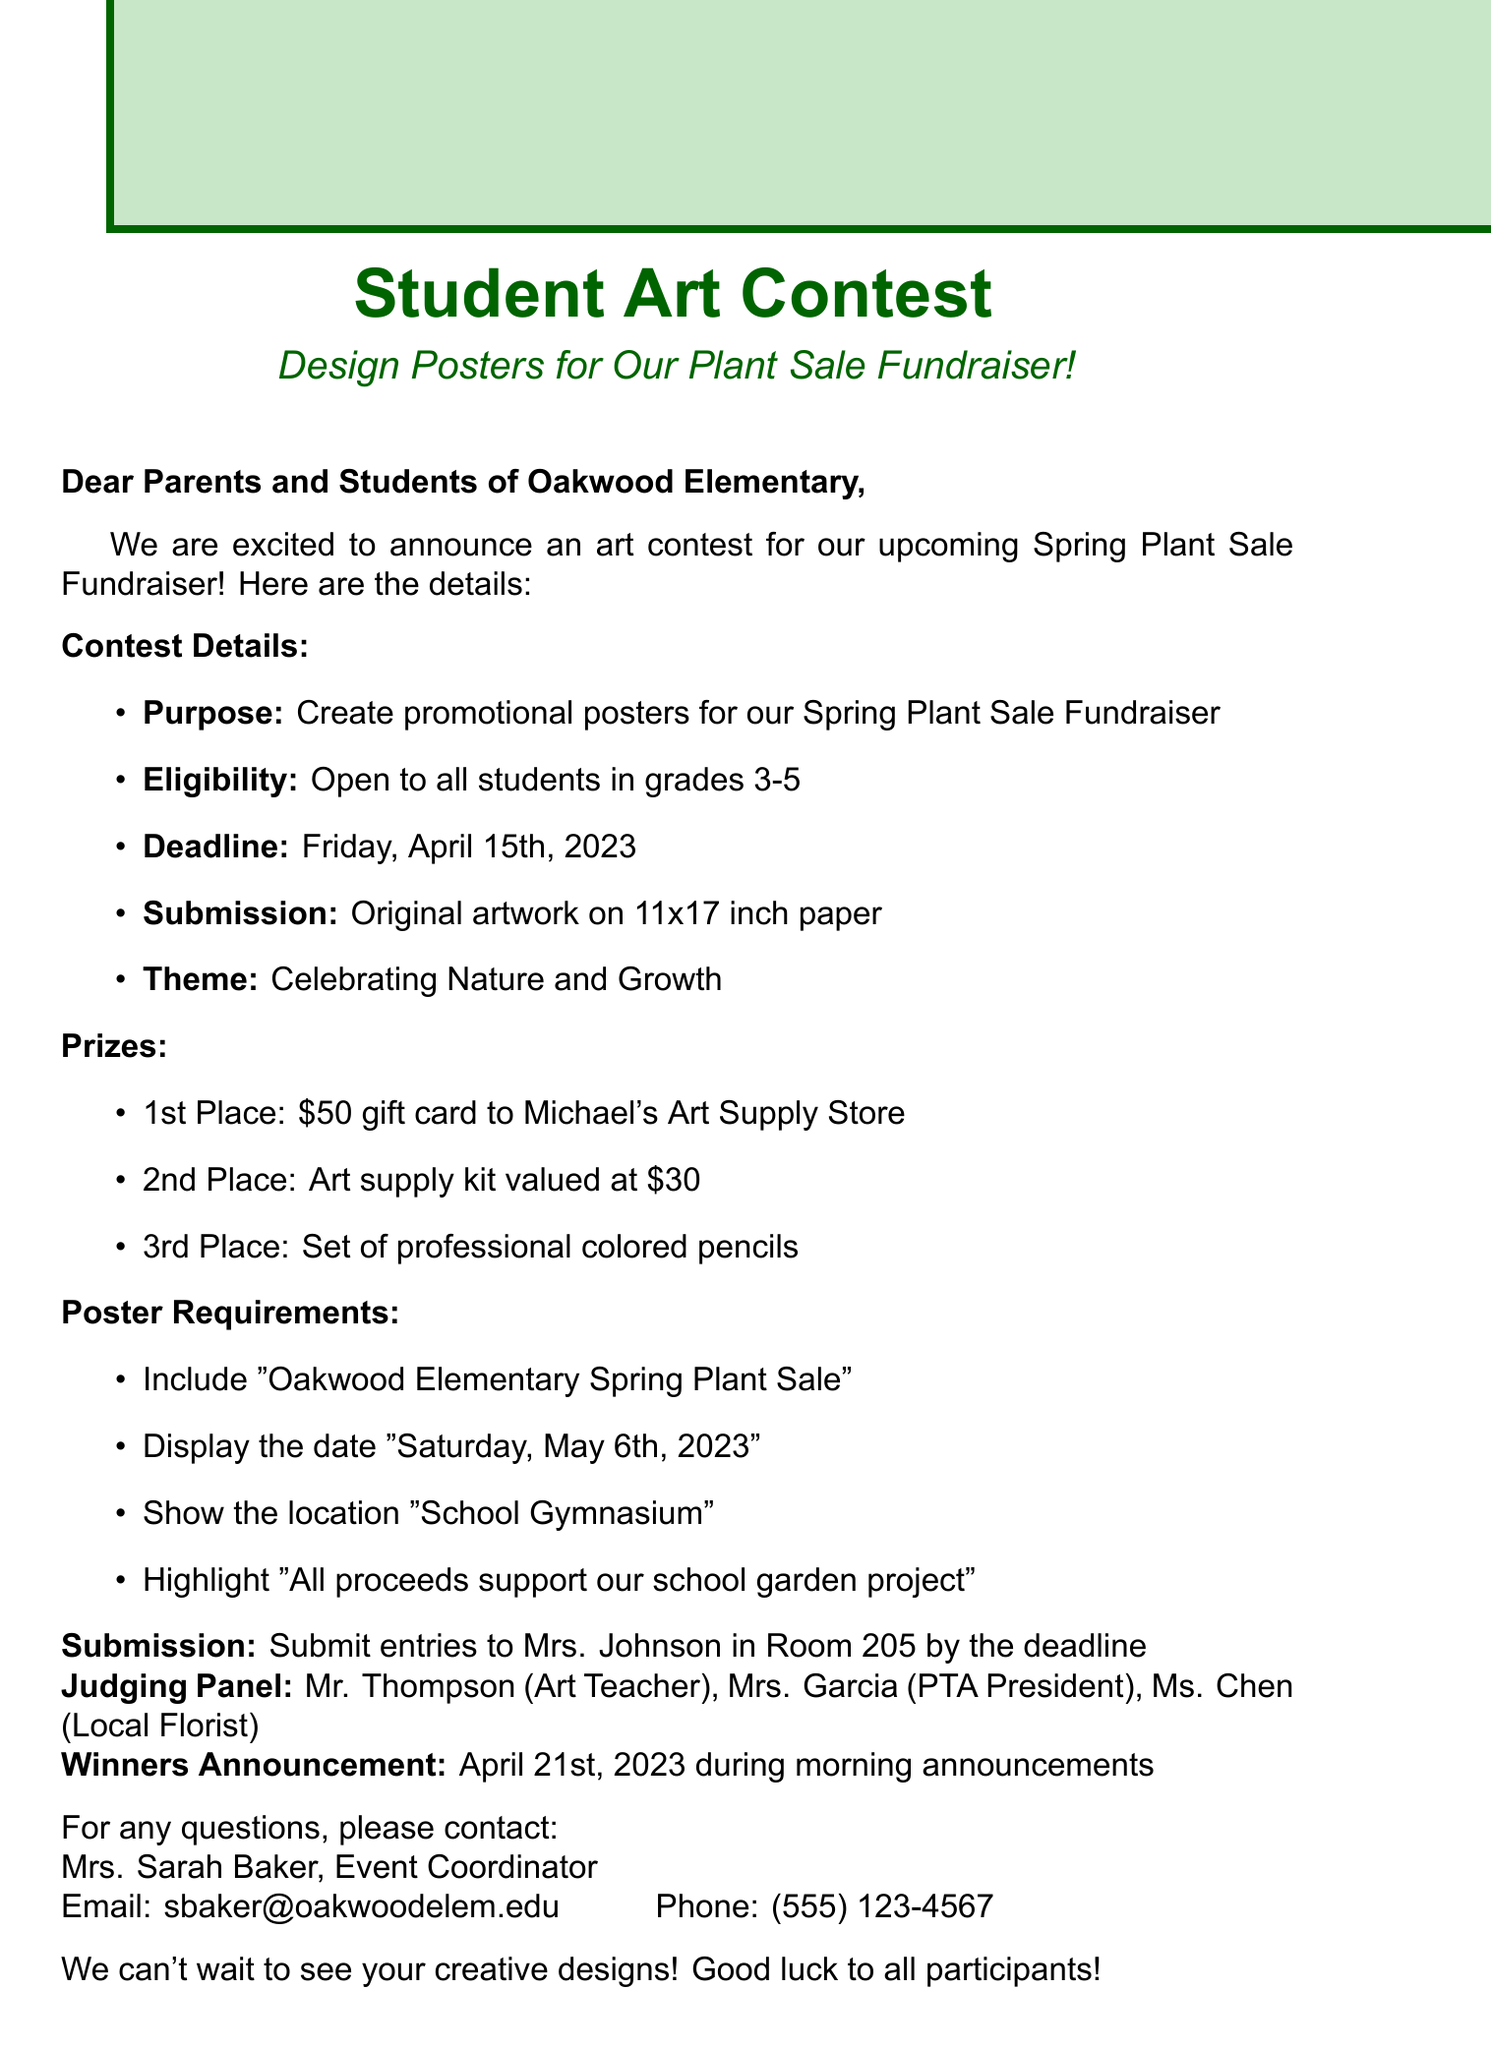What is the purpose of the art contest? The purpose is to create promotional posters for the Spring Plant Sale Fundraiser.
Answer: Create promotional posters for our Spring Plant Sale Fundraiser Who is eligible to participate in the contest? The eligibility specifies students in grades 3-5 can enter the contest.
Answer: All students in grades 3-5 What is the submission deadline? The deadline for submitting entries to the contest is provided in the document.
Answer: Friday, April 15th, 2023 What is the theme of the contest? The theme that participants must adhere to for their artwork is listed.
Answer: Celebrating Nature and Growth What are the prizes for the winners? The document specifically lists different prizes for 1st, 2nd, and 3rd places.
Answer: $50 gift card to Michael's Art Supply Store Who will be judging the contest? The names of the individuals on the judging panel are mentioned.
Answer: Mr. Thompson, Mrs. Garcia, Ms. Chen When will the winners be announced? The date provided for announcing the winners is stated in the document.
Answer: April 21st, 2023 Where should entries be submitted? The document specifies the location for submission of entries.
Answer: Room 205 What should be included in the posters? The key elements that must be displayed on the posters are described.
Answer: Oakwood Elementary Spring Plant Sale Who can be contacted for questions about the contest? The document provides contact information for the event coordinator for any inquiries.
Answer: Mrs. Sarah Baker 